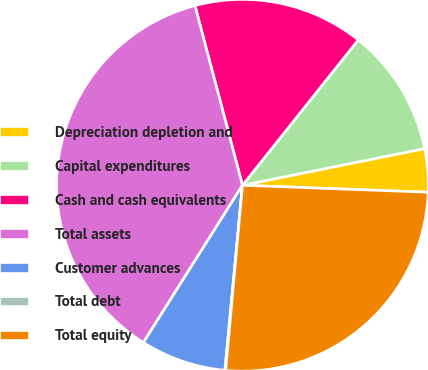<chart> <loc_0><loc_0><loc_500><loc_500><pie_chart><fcel>Depreciation depletion and<fcel>Capital expenditures<fcel>Cash and cash equivalents<fcel>Total assets<fcel>Customer advances<fcel>Total debt<fcel>Total equity<nl><fcel>3.76%<fcel>11.13%<fcel>14.82%<fcel>36.94%<fcel>7.44%<fcel>0.07%<fcel>25.84%<nl></chart> 